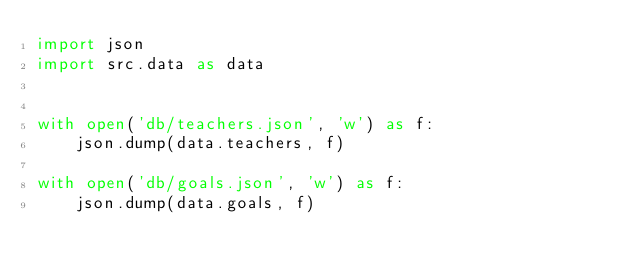<code> <loc_0><loc_0><loc_500><loc_500><_Python_>import json
import src.data as data


with open('db/teachers.json', 'w') as f:
    json.dump(data.teachers, f)

with open('db/goals.json', 'w') as f:
    json.dump(data.goals, f)
</code> 